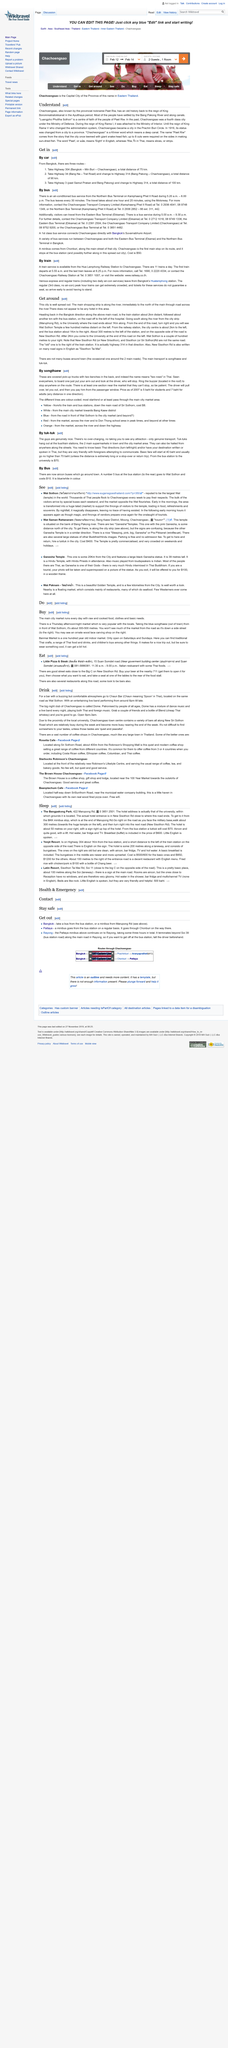Mention a couple of crucial points in this snapshot. Banmai Market is a one hundred year old indoor market. There are 11 trains running daily from Hua Lamphong railway station to Chachoengsao. Banmai Market offers a diverse selection of items, including traditional Thai crafts, a variety of Thai food and drinks, and children's toys, among other items. The bus service for visitors that travel from the Eastern Bus Terminal (Ekkamai) ends at 9:30 p.m. The first train departs Hua Lamphong railway station for Chachoengsao at 5.55am every day. 